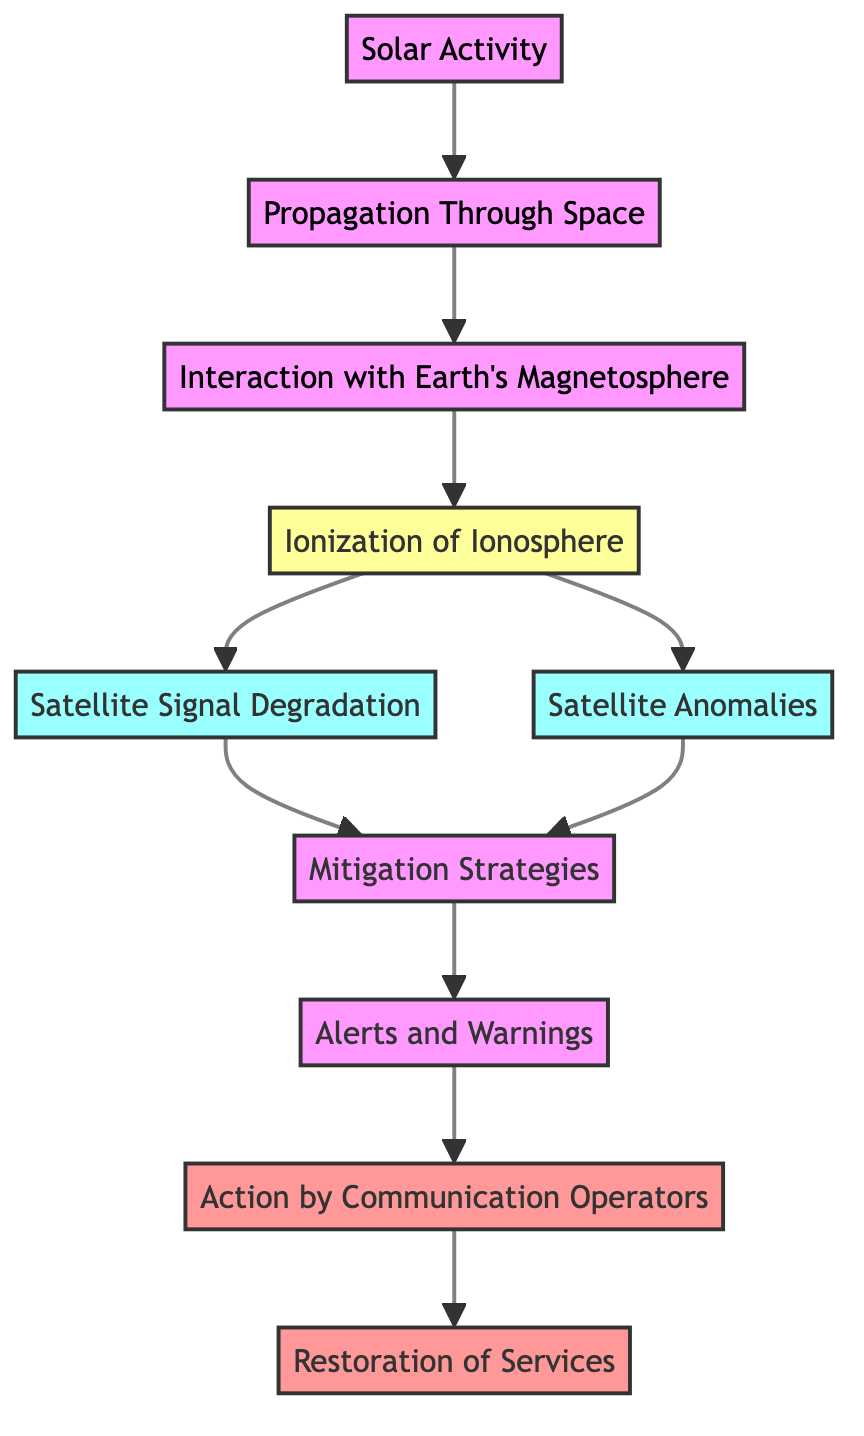What is the first step in the diagram? The first step is "Solar Activity," which is the origin of space weather events such as solar flares and CMEs.
Answer: Solar Activity How many main nodes are in the diagram? Counting the nodes represented in the diagram, there are a total of ten main nodes that describe different aspects of space weather's impact on satellite communications.
Answer: 10 What follows the "Interaction with Earth's Magnetosphere"? The next node following "Interaction with Earth's Magnetosphere" is "Ionization of Ionosphere," indicating that interaction leads to ionization changes.
Answer: Ionization of Ionosphere Which two nodes are linked to "Ionization of Ionosphere"? The two nodes linked to "Ionization of Ionosphere" are "Satellite Signal Degradation" and "Satellite Anomalies," showing the effects of ionization on satellite operations.
Answer: Satellite Signal Degradation and Satellite Anomalies What action is taken after "Alerts and Warnings"? Following "Alerts and Warnings," the action taken is by "Action by Communication Operators," which indicates steps taken by operators for satellite communication services.
Answer: Action by Communication Operators What is the final outcome or goal in the flowchart? The final outcome in the flowchart is "Restoration of Services," which describes the recovery efforts to restore affected satellite communications after an event.
Answer: Restoration of Services What role do "Mitigation Strategies" play in the flowchart? "Mitigation Strategies" act as a bridge between the degradation of signals and the subsequent actions taken to respond to space weather impacts, indicating their preventive and responsive significance.
Answer: Techniques to mitigate space weather impact What is the last node related to satellite communication? The last node related to satellite communication in the flowchart is "Restoration of Services," indicating the conclusion of recovery efforts and return to normal operation.
Answer: Restoration of Services How does "Propagation Through Space" connect to the next step? "Propagation Through Space" connects to "Interaction with Earth's Magnetosphere," showing that the solar activity's effects travel through space and interact with Earth's magnetic field.
Answer: Interaction with Earth's Magnetosphere 